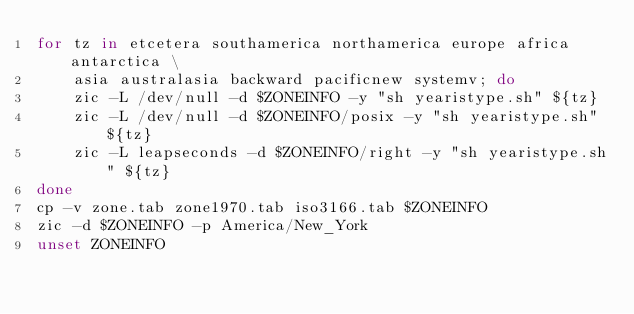<code> <loc_0><loc_0><loc_500><loc_500><_Bash_>for tz in etcetera southamerica northamerica europe africa antarctica \
    asia australasia backward pacificnew systemv; do
    zic -L /dev/null -d $ZONEINFO -y "sh yearistype.sh" ${tz}
    zic -L /dev/null -d $ZONEINFO/posix -y "sh yearistype.sh" ${tz}
    zic -L leapseconds -d $ZONEINFO/right -y "sh yearistype.sh" ${tz}
done
cp -v zone.tab zone1970.tab iso3166.tab $ZONEINFO
zic -d $ZONEINFO -p America/New_York
unset ZONEINFO
</code> 